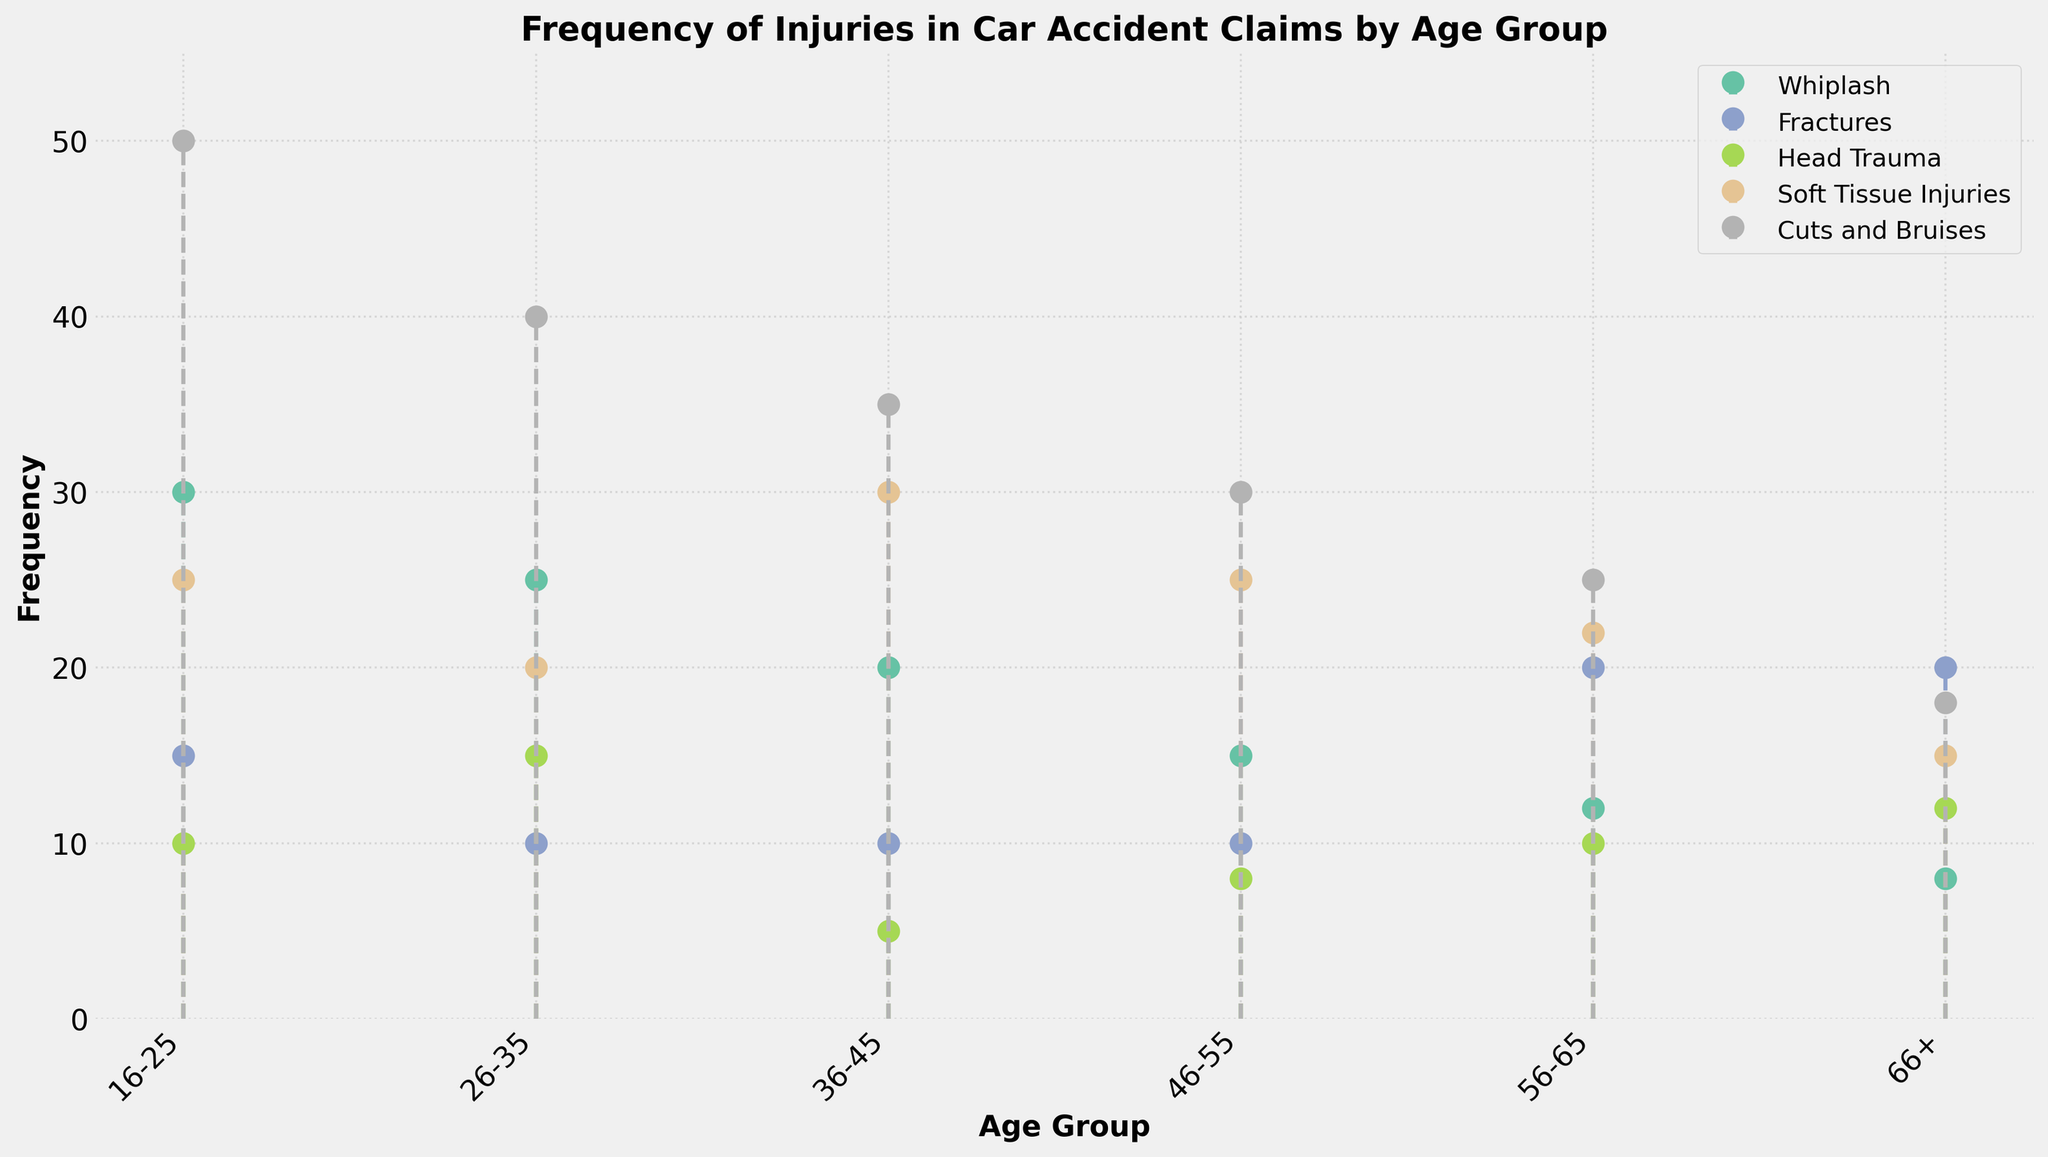what is the title of the plot? The title of the plot is clearly displayed at the top of the figure, indicating the subject of the visualization.
Answer: Frequency of Injuries in Car Accident Claims by Age Group How many different injury types are presented in the plot? By counting the unique markers and labels in the legend, you can determine the number of distinct injury types.
Answer: Five What is the frequency of fractures in the 26-35 age group? Locate the "Fractures" injury type and the corresponding point for the 26-35 age group on the x-axis. The vertical marker indicates the frequency value.
Answer: 10 Which age group has the highest frequency of head trauma? Compare the frequencies of "Head Trauma" across all age groups by examining the corresponding markers.
Answer: 66+ How does the frequency of soft tissue injuries change from the 16-25 age group to the 36-45 age group? Compare the vertical positions of the markers for "Soft Tissue Injuries" in the 16-25 and 36-45 age groups to see the numerical change.
Answer: Increases from 25 to 30 What is the combined frequency of whiplash injuries for the age groups 46-55 and 66+? Sum the frequencies of "Whiplash" injuries in the 46-55 and 66+ age groups.
Answer: 15 + 8 = 23 Among all age groups, which displays the highest overall frequency for cuts and bruises? Compare the marker heights for "Cuts and Bruises" across all age groups and find the highest one by visual observation.
Answer: 16-25 Which age group shows the lowest frequency of fractures? Identify the lowest point in the graph for "Fractures" by comparing the marker positions for all age groups.
Answer: 26-35 and 36-45 (both 10) For the 56-65 age group, what is the total frequency of all types of injuries combined? Sum the frequencies of all injury types for the 56-65 age group. Add up the individual frequencies visible in their respective markers.
Answer: 12 + 20 + 10 + 22 + 25 = 89 